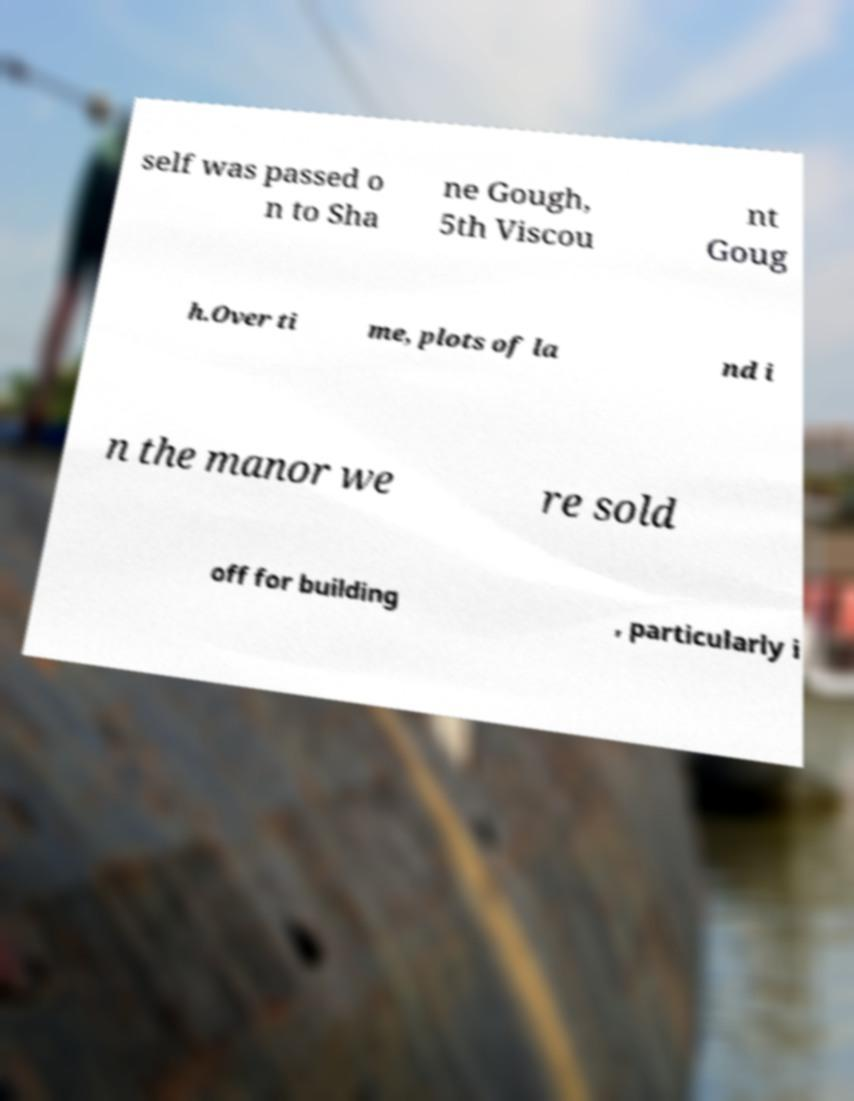Can you accurately transcribe the text from the provided image for me? self was passed o n to Sha ne Gough, 5th Viscou nt Goug h.Over ti me, plots of la nd i n the manor we re sold off for building , particularly i 